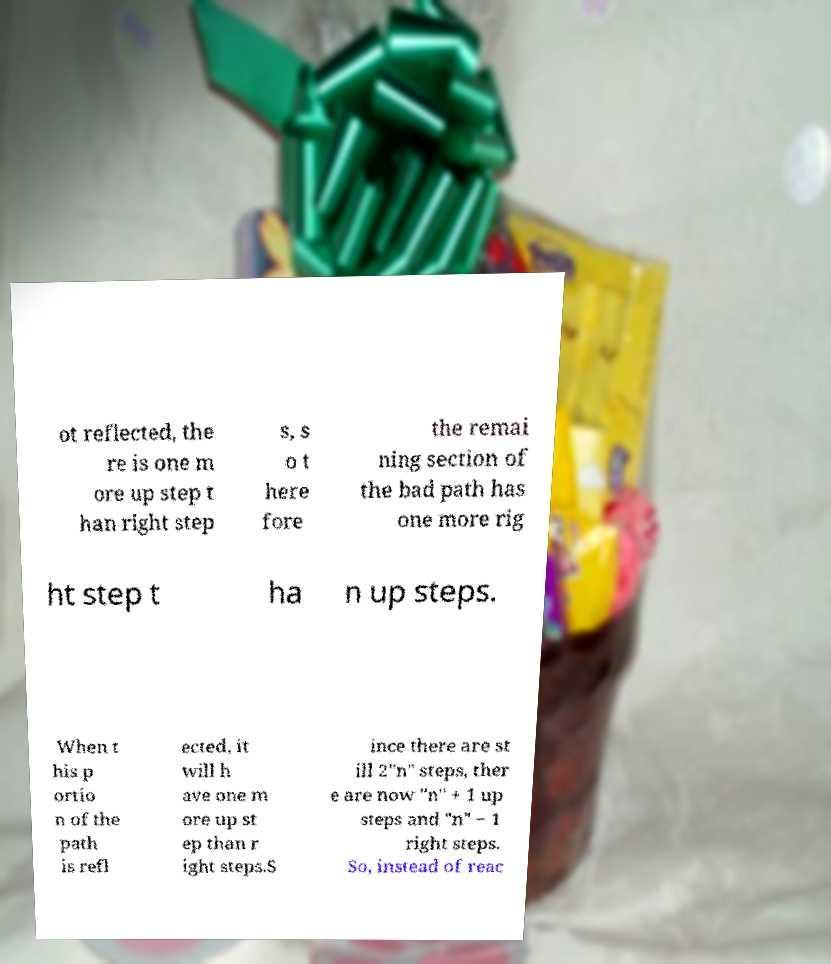There's text embedded in this image that I need extracted. Can you transcribe it verbatim? ot reflected, the re is one m ore up step t han right step s, s o t here fore the remai ning section of the bad path has one more rig ht step t ha n up steps. When t his p ortio n of the path is refl ected, it will h ave one m ore up st ep than r ight steps.S ince there are st ill 2"n" steps, ther e are now "n" + 1 up steps and "n" − 1 right steps. So, instead of reac 